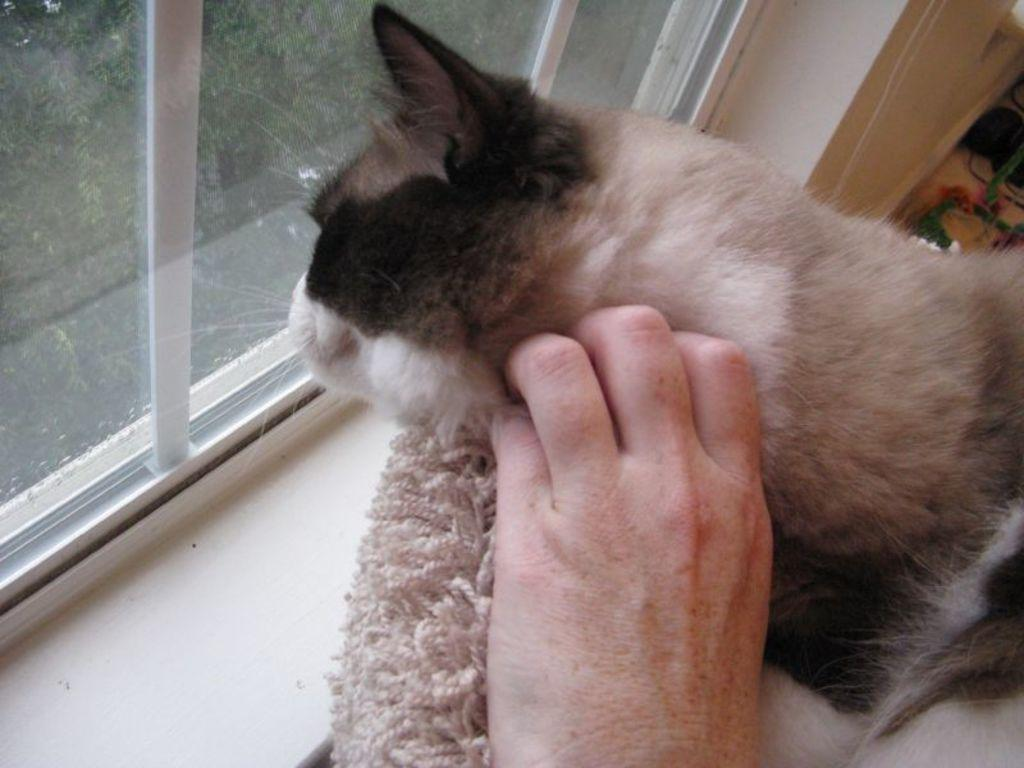What type of animal is present in the image? There is a cat in the picture. What part of a human body can be seen in the image? There is a human hand in the picture. What type of structure is visible in the image? There is a glass window in the picture. What object made of fabric is present in the image? There is a cloth in the picture. What type of fruit is being sold at the store in the image? There is no store present in the image, and therefore no fruit can be sold. What is the quince doing in the scene? There is no quince present in the image, so it cannot be doing anything. 